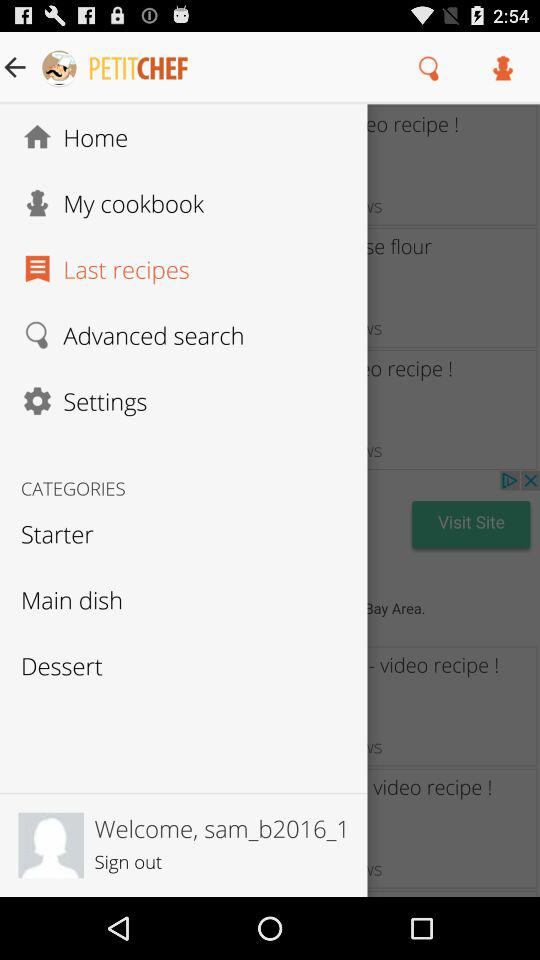What is the application name? The application name is "PETITCHEF". 